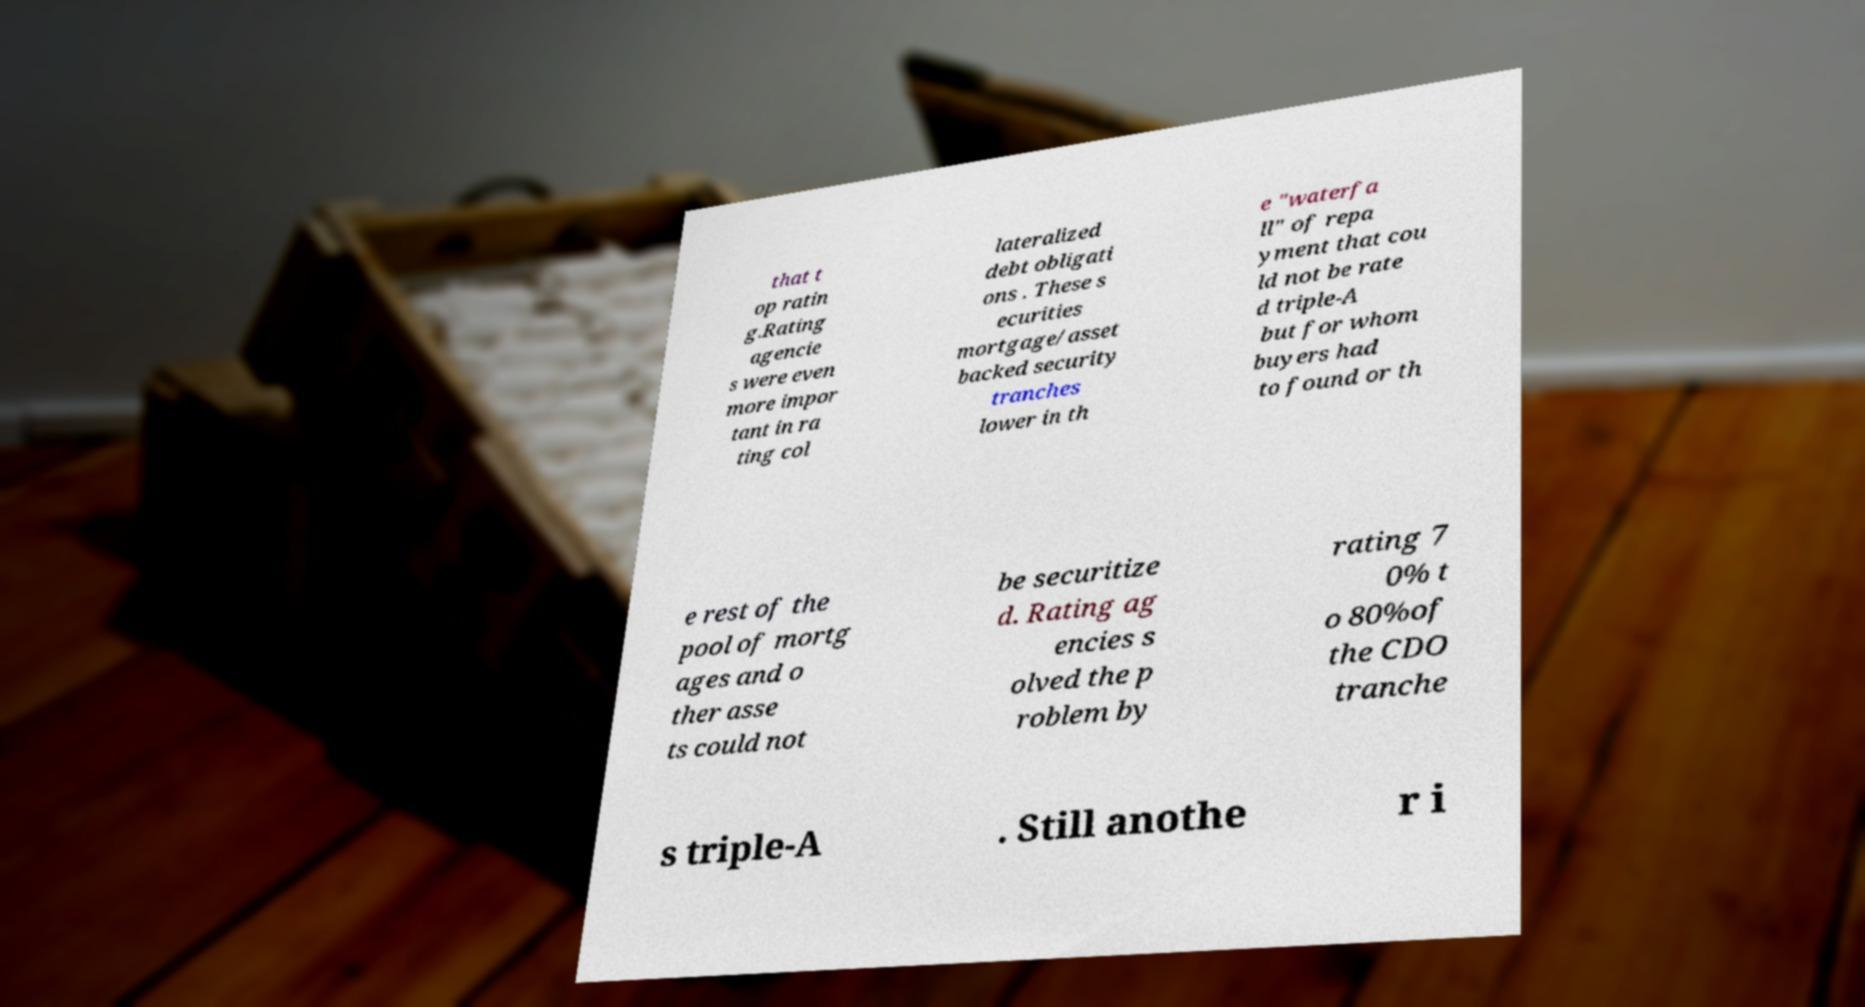What messages or text are displayed in this image? I need them in a readable, typed format. that t op ratin g.Rating agencie s were even more impor tant in ra ting col lateralized debt obligati ons . These s ecurities mortgage/asset backed security tranches lower in th e "waterfa ll" of repa yment that cou ld not be rate d triple-A but for whom buyers had to found or th e rest of the pool of mortg ages and o ther asse ts could not be securitize d. Rating ag encies s olved the p roblem by rating 7 0% t o 80%of the CDO tranche s triple-A . Still anothe r i 